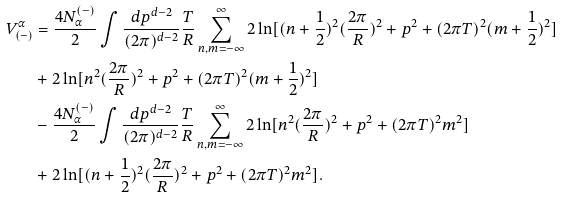<formula> <loc_0><loc_0><loc_500><loc_500>V _ { ( - ) } ^ { \alpha } & = \frac { 4 N ^ { ( - ) } _ { \alpha } } { 2 } \int \frac { d p ^ { d - 2 } } { ( 2 \pi ) ^ { d - 2 } } \frac { T } { R } \sum _ { n , m = - \infty } ^ { \infty } 2 \ln [ ( n + \frac { 1 } { 2 } ) ^ { 2 } ( \frac { 2 \pi } { R } ) ^ { 2 } + p ^ { 2 } + ( 2 \pi { T } ) ^ { 2 } ( m + \frac { 1 } { 2 } ) ^ { 2 } ] \\ & + 2 \ln [ n ^ { 2 } ( \frac { 2 \pi } { R } ) ^ { 2 } + p ^ { 2 } + ( 2 \pi { T } ) ^ { 2 } ( m + \frac { 1 } { 2 } ) ^ { 2 } ] \\ & - \frac { 4 N ^ { ( - ) } _ { \alpha } } { 2 } \int \frac { d p ^ { d - 2 } } { ( 2 \pi ) ^ { d - 2 } } \frac { T } { R } \sum _ { n , m = - \infty } ^ { \infty } 2 \ln [ n ^ { 2 } ( \frac { 2 \pi } { R } ) ^ { 2 } + p ^ { 2 } + ( 2 \pi { T } ) ^ { 2 } m ^ { 2 } ] \\ & + 2 \ln [ ( n + \frac { 1 } { 2 } ) ^ { 2 } ( \frac { 2 \pi } { R } ) ^ { 2 } + p ^ { 2 } + ( 2 \pi { T } ) ^ { 2 } m ^ { 2 } ] .</formula> 